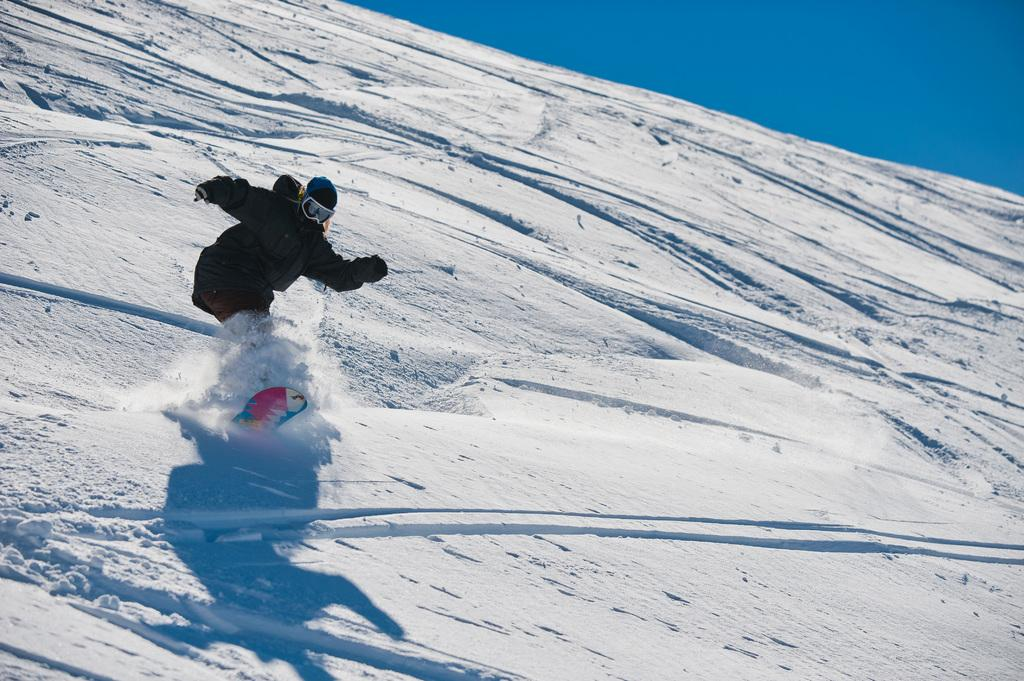What is the main subject of the image? There is a human in the image. What activity is the human engaged in? The human is standing on a snowboard and surfing in the snow. What protective gear is the human wearing? The human is wearing a helmet and sunglasses. What is the color of the sky in the image? The sky is blue in the image. Can you tell me how many snakes are slithering around the human's feet in the image? There are no snakes present in the image; the human is snowboarding. What time of day is it in the image? The provided facts do not mention the time of day, so it cannot be determined from the image. 